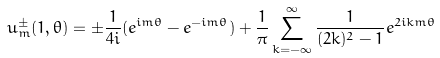Convert formula to latex. <formula><loc_0><loc_0><loc_500><loc_500>u _ { m } ^ { \pm } ( 1 , \theta ) = \pm \frac { 1 } { 4 i } ( e ^ { i m \theta } - e ^ { - i m \theta } ) + \frac { 1 } { \pi } \sum _ { k = - \infty } ^ { \infty } \frac { 1 } { ( 2 k ) ^ { 2 } - 1 } e ^ { 2 i k m \theta }</formula> 